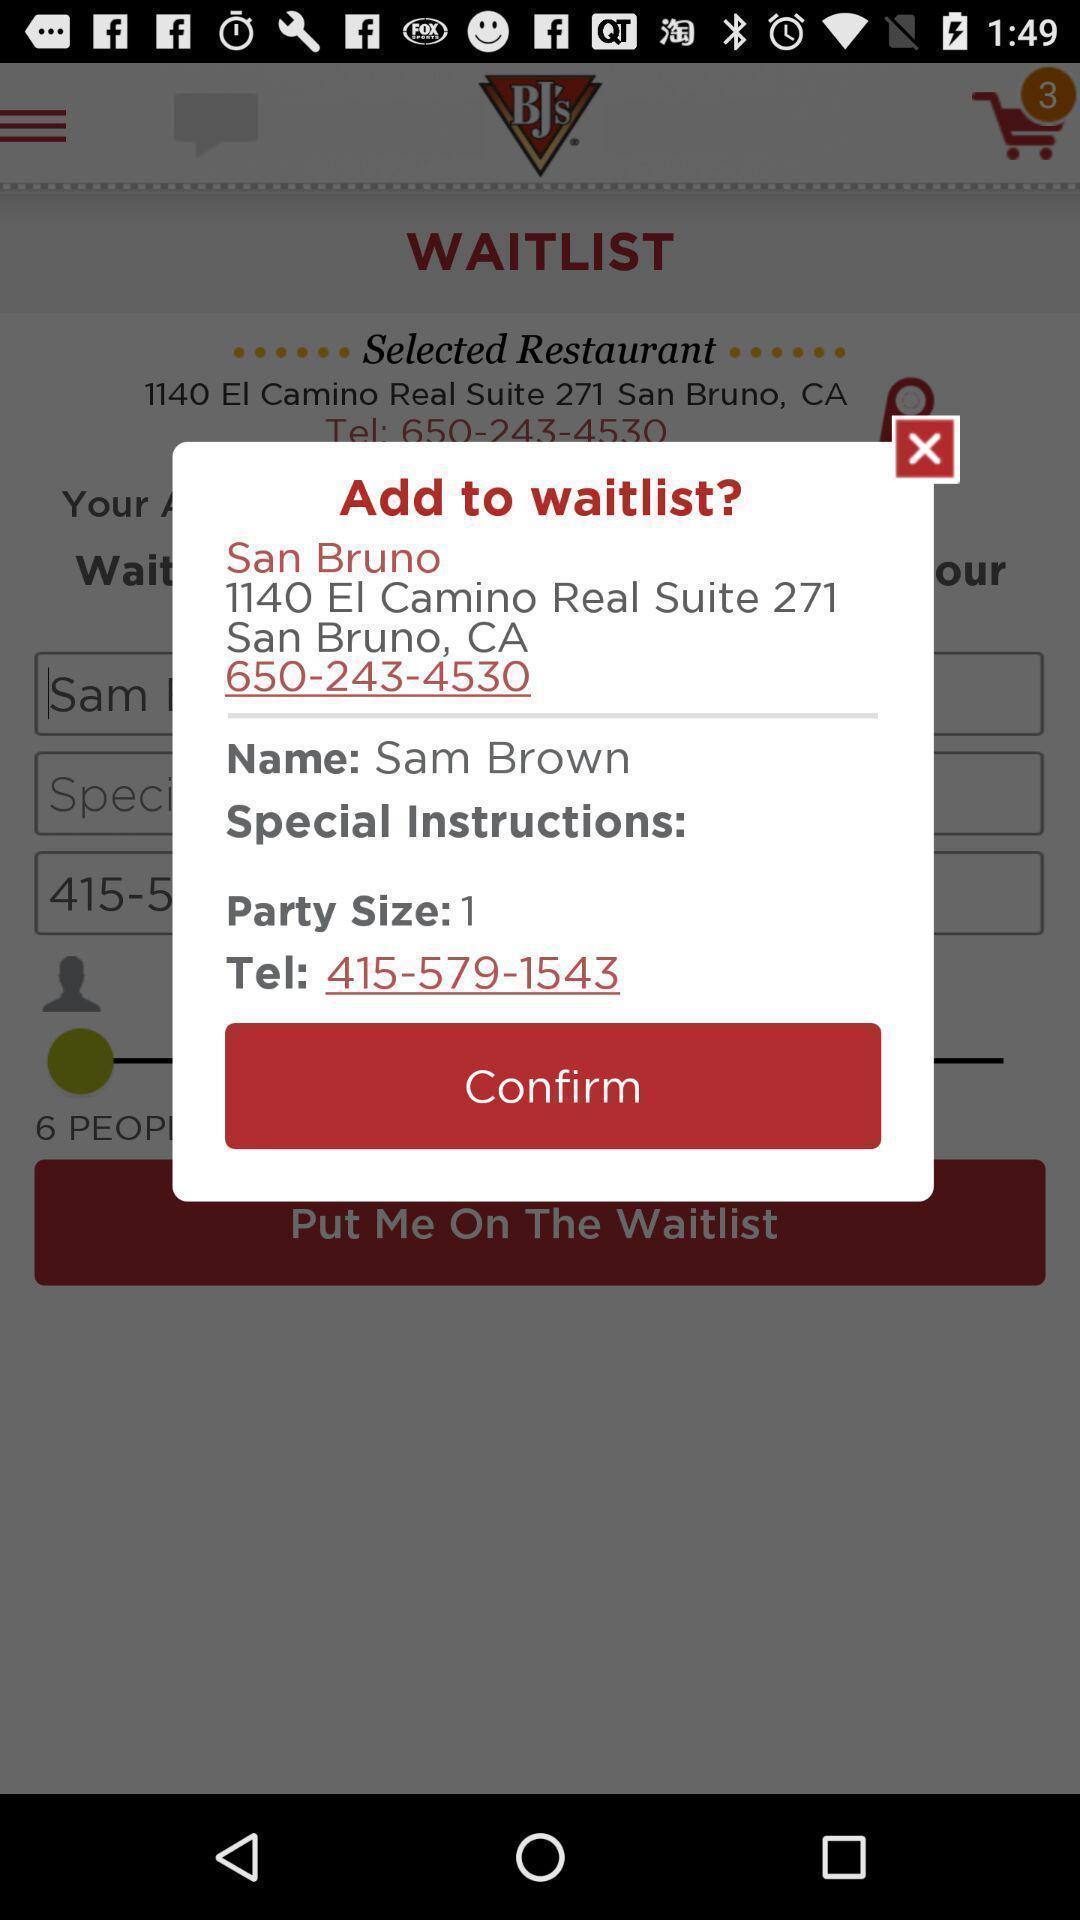Explain the elements present in this screenshot. Pop-up displaying the details to add to waitlist. 